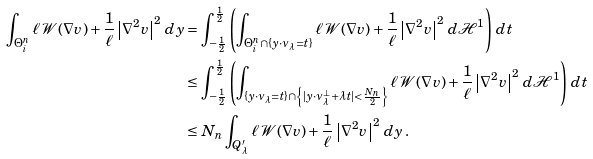Convert formula to latex. <formula><loc_0><loc_0><loc_500><loc_500>\int _ { \Theta _ { i } ^ { n } } \ell \, \mathcal { W } ( \nabla v ) + \frac { 1 } { \ell } \left | \nabla ^ { 2 } v \right | ^ { 2 } \, d y & = \int _ { - \frac { 1 } { 2 } } ^ { \frac { 1 } { 2 } } \left ( \int _ { \Theta _ { i } ^ { n } \cap \{ y \cdot \nu _ { \lambda } = t \} } \ell \, \mathcal { W } ( \nabla v ) + \frac { 1 } { \ell } \left | \nabla ^ { 2 } v \right | ^ { 2 } \, d \mathcal { H } ^ { 1 } \right ) \, d t \\ & \leq \int _ { - \frac { 1 } { 2 } } ^ { \frac { 1 } { 2 } } \left ( \int _ { \{ y \cdot \nu _ { \lambda } = t \} \cap \left \{ | y \cdot \nu ^ { \perp } _ { \lambda } + \lambda t | < \frac { N _ { n } } { 2 } \right \} } \ell \, \mathcal { W } ( \nabla v ) + \frac { 1 } { \ell } \left | \nabla ^ { 2 } v \right | ^ { 2 } \, d \mathcal { H } ^ { 1 } \right ) \, d t \\ & \leq N _ { n } \int _ { Q ^ { \prime } _ { \lambda } } \ell \, \mathcal { W } ( \nabla v ) + \frac { 1 } { \ell } \left | \nabla ^ { 2 } v \right | ^ { 2 } \, d y \, .</formula> 